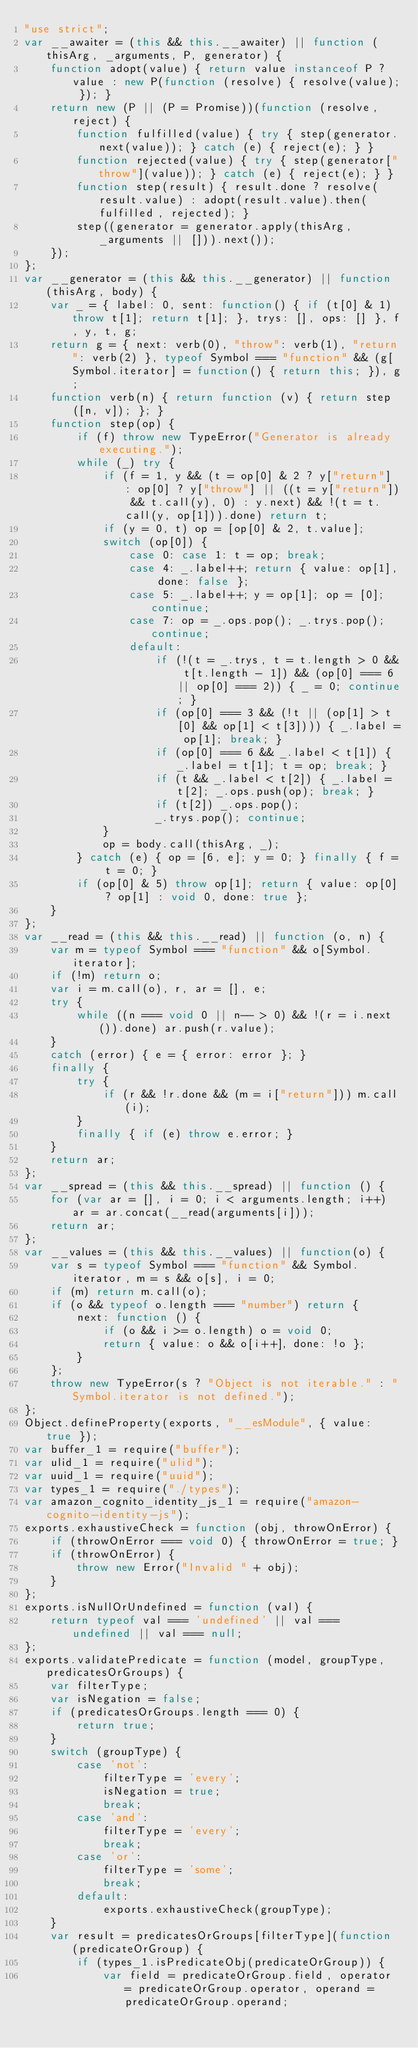Convert code to text. <code><loc_0><loc_0><loc_500><loc_500><_JavaScript_>"use strict";
var __awaiter = (this && this.__awaiter) || function (thisArg, _arguments, P, generator) {
    function adopt(value) { return value instanceof P ? value : new P(function (resolve) { resolve(value); }); }
    return new (P || (P = Promise))(function (resolve, reject) {
        function fulfilled(value) { try { step(generator.next(value)); } catch (e) { reject(e); } }
        function rejected(value) { try { step(generator["throw"](value)); } catch (e) { reject(e); } }
        function step(result) { result.done ? resolve(result.value) : adopt(result.value).then(fulfilled, rejected); }
        step((generator = generator.apply(thisArg, _arguments || [])).next());
    });
};
var __generator = (this && this.__generator) || function (thisArg, body) {
    var _ = { label: 0, sent: function() { if (t[0] & 1) throw t[1]; return t[1]; }, trys: [], ops: [] }, f, y, t, g;
    return g = { next: verb(0), "throw": verb(1), "return": verb(2) }, typeof Symbol === "function" && (g[Symbol.iterator] = function() { return this; }), g;
    function verb(n) { return function (v) { return step([n, v]); }; }
    function step(op) {
        if (f) throw new TypeError("Generator is already executing.");
        while (_) try {
            if (f = 1, y && (t = op[0] & 2 ? y["return"] : op[0] ? y["throw"] || ((t = y["return"]) && t.call(y), 0) : y.next) && !(t = t.call(y, op[1])).done) return t;
            if (y = 0, t) op = [op[0] & 2, t.value];
            switch (op[0]) {
                case 0: case 1: t = op; break;
                case 4: _.label++; return { value: op[1], done: false };
                case 5: _.label++; y = op[1]; op = [0]; continue;
                case 7: op = _.ops.pop(); _.trys.pop(); continue;
                default:
                    if (!(t = _.trys, t = t.length > 0 && t[t.length - 1]) && (op[0] === 6 || op[0] === 2)) { _ = 0; continue; }
                    if (op[0] === 3 && (!t || (op[1] > t[0] && op[1] < t[3]))) { _.label = op[1]; break; }
                    if (op[0] === 6 && _.label < t[1]) { _.label = t[1]; t = op; break; }
                    if (t && _.label < t[2]) { _.label = t[2]; _.ops.push(op); break; }
                    if (t[2]) _.ops.pop();
                    _.trys.pop(); continue;
            }
            op = body.call(thisArg, _);
        } catch (e) { op = [6, e]; y = 0; } finally { f = t = 0; }
        if (op[0] & 5) throw op[1]; return { value: op[0] ? op[1] : void 0, done: true };
    }
};
var __read = (this && this.__read) || function (o, n) {
    var m = typeof Symbol === "function" && o[Symbol.iterator];
    if (!m) return o;
    var i = m.call(o), r, ar = [], e;
    try {
        while ((n === void 0 || n-- > 0) && !(r = i.next()).done) ar.push(r.value);
    }
    catch (error) { e = { error: error }; }
    finally {
        try {
            if (r && !r.done && (m = i["return"])) m.call(i);
        }
        finally { if (e) throw e.error; }
    }
    return ar;
};
var __spread = (this && this.__spread) || function () {
    for (var ar = [], i = 0; i < arguments.length; i++) ar = ar.concat(__read(arguments[i]));
    return ar;
};
var __values = (this && this.__values) || function(o) {
    var s = typeof Symbol === "function" && Symbol.iterator, m = s && o[s], i = 0;
    if (m) return m.call(o);
    if (o && typeof o.length === "number") return {
        next: function () {
            if (o && i >= o.length) o = void 0;
            return { value: o && o[i++], done: !o };
        }
    };
    throw new TypeError(s ? "Object is not iterable." : "Symbol.iterator is not defined.");
};
Object.defineProperty(exports, "__esModule", { value: true });
var buffer_1 = require("buffer");
var ulid_1 = require("ulid");
var uuid_1 = require("uuid");
var types_1 = require("./types");
var amazon_cognito_identity_js_1 = require("amazon-cognito-identity-js");
exports.exhaustiveCheck = function (obj, throwOnError) {
    if (throwOnError === void 0) { throwOnError = true; }
    if (throwOnError) {
        throw new Error("Invalid " + obj);
    }
};
exports.isNullOrUndefined = function (val) {
    return typeof val === 'undefined' || val === undefined || val === null;
};
exports.validatePredicate = function (model, groupType, predicatesOrGroups) {
    var filterType;
    var isNegation = false;
    if (predicatesOrGroups.length === 0) {
        return true;
    }
    switch (groupType) {
        case 'not':
            filterType = 'every';
            isNegation = true;
            break;
        case 'and':
            filterType = 'every';
            break;
        case 'or':
            filterType = 'some';
            break;
        default:
            exports.exhaustiveCheck(groupType);
    }
    var result = predicatesOrGroups[filterType](function (predicateOrGroup) {
        if (types_1.isPredicateObj(predicateOrGroup)) {
            var field = predicateOrGroup.field, operator = predicateOrGroup.operator, operand = predicateOrGroup.operand;</code> 